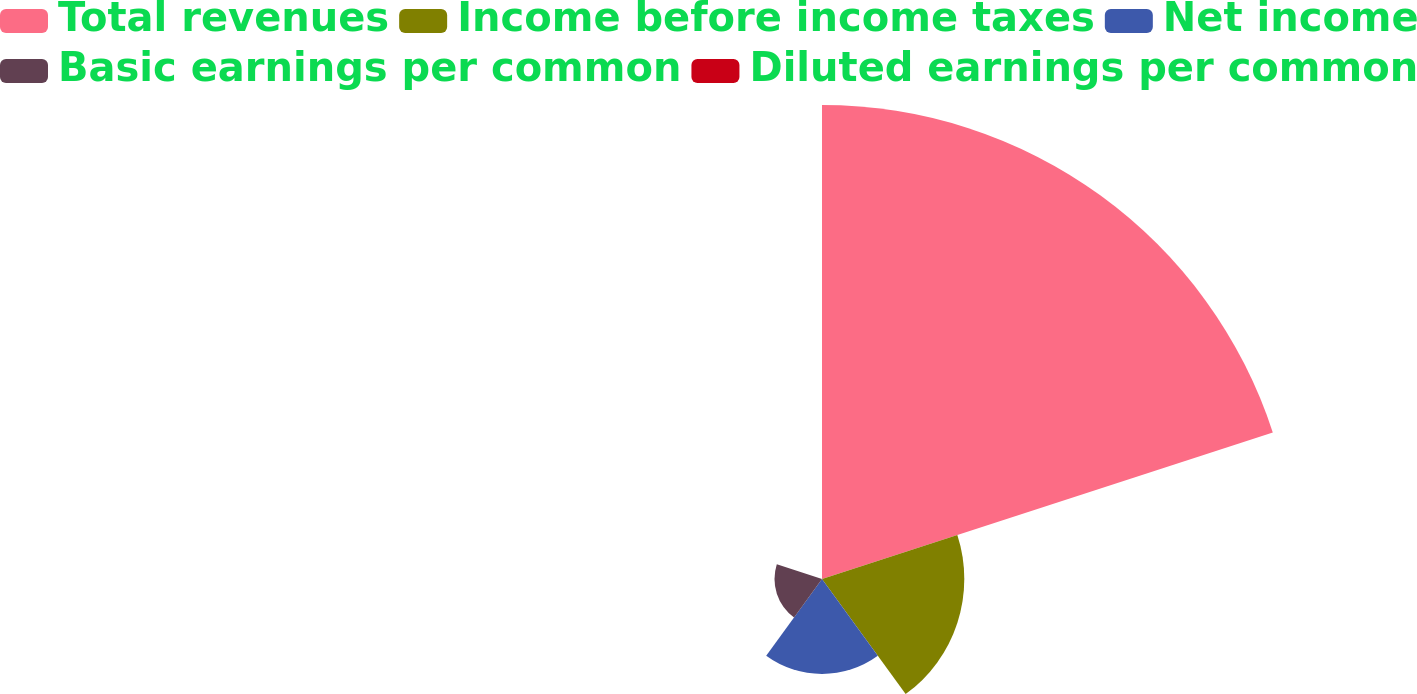Convert chart to OTSL. <chart><loc_0><loc_0><loc_500><loc_500><pie_chart><fcel>Total revenues<fcel>Income before income taxes<fcel>Net income<fcel>Basic earnings per common<fcel>Diluted earnings per common<nl><fcel>62.46%<fcel>18.75%<fcel>12.51%<fcel>6.26%<fcel>0.02%<nl></chart> 